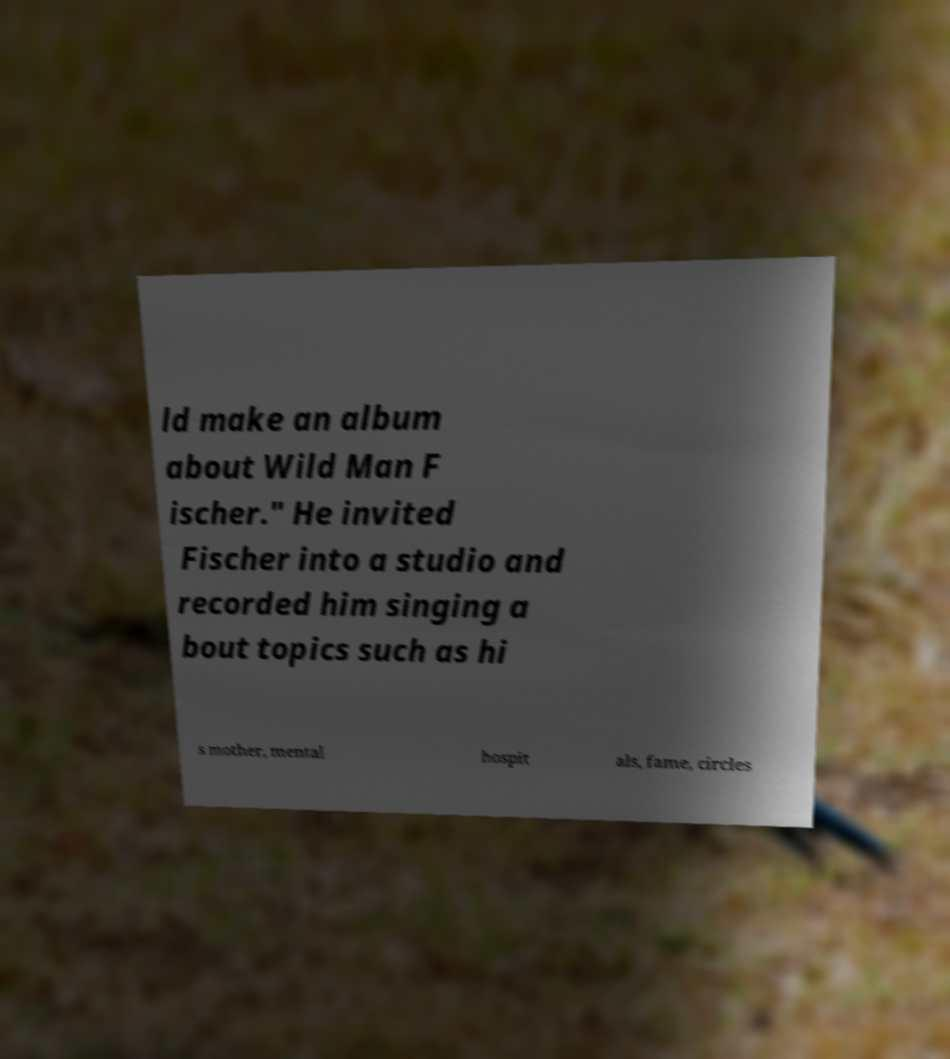I need the written content from this picture converted into text. Can you do that? ld make an album about Wild Man F ischer." He invited Fischer into a studio and recorded him singing a bout topics such as hi s mother, mental hospit als, fame, circles 